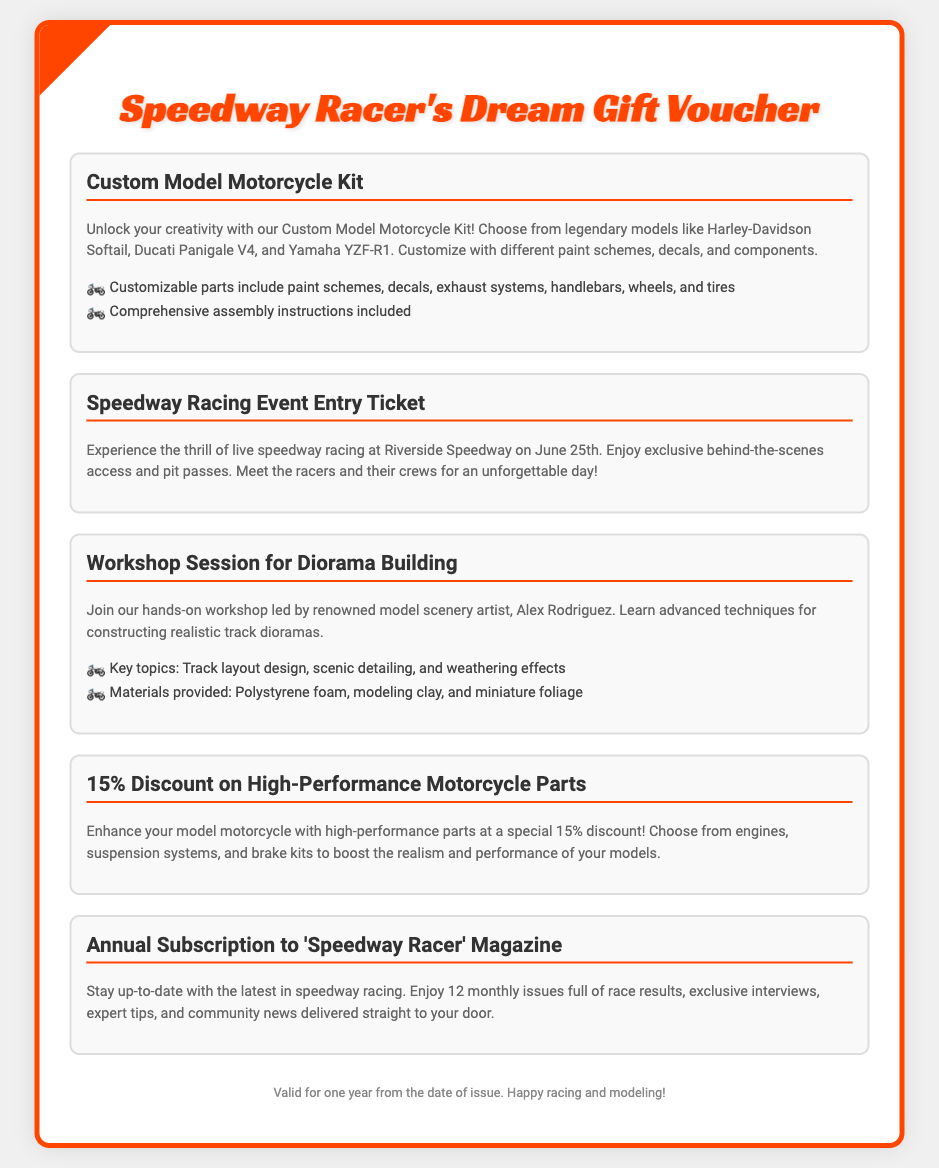What is included in the Custom Model Motorcycle Kit? The kit includes legendary models, customizable parts, and comprehensive assembly instructions.
Answer: Customizable parts When will the Speedway Racing Event take place? The date of the event is explicitly mentioned in the document section about the Speedway Racing Event.
Answer: June 25th Who is leading the Diorama Building workshop? The document specifies the name of the renowned model scenery artist who will conduct the workshop.
Answer: Alex Rodriguez What discount is offered on High-Performance Motorcycle Parts? The percentage discount for enhancing model motorcycles with high-performance parts is detailed in the relevant section.
Answer: 15% What is the name of the magazine included in the subscription? The title of the magazine that subscribers will receive is mentioned in the gift item description.
Answer: 'Speedway Racer' Magazine What are key topics covered in the Diorama Building workshop? The document lists topics that will be part of the workshop on diorama construction.
Answer: Track layout design, scenic detailing, and weathering effects Is the voucher valid for a limited time? The document contains information about the validity of the voucher.
Answer: One year What materials are provided in the Diorama workshop? The specific materials included for workshop participants are mentioned in the document.
Answer: Polystyrene foam, modeling clay, and miniature foliage 